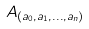<formula> <loc_0><loc_0><loc_500><loc_500>A _ { ( a _ { 0 } , a _ { 1 } , \dots , a _ { n } ) }</formula> 